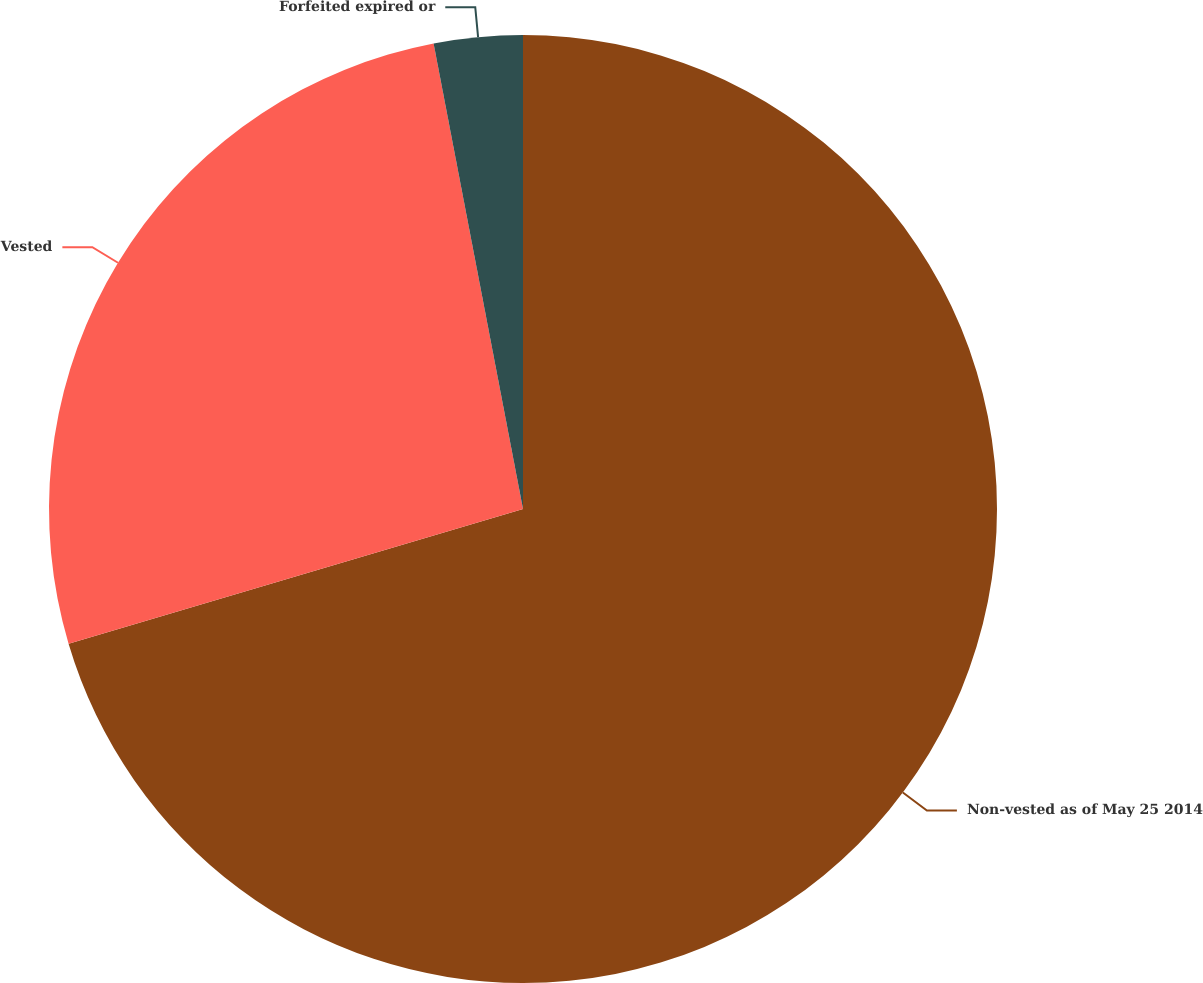Convert chart. <chart><loc_0><loc_0><loc_500><loc_500><pie_chart><fcel>Non-vested as of May 25 2014<fcel>Vested<fcel>Forfeited expired or<nl><fcel>70.41%<fcel>26.57%<fcel>3.02%<nl></chart> 